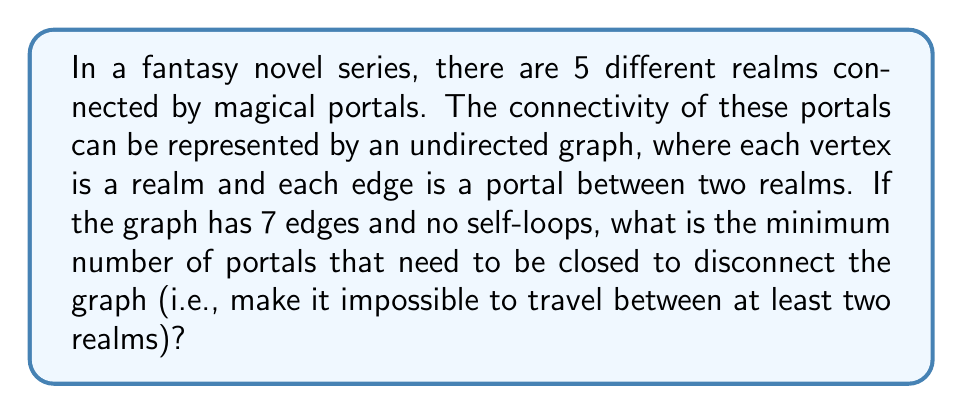Teach me how to tackle this problem. To solve this problem, we need to understand the concept of edge connectivity in graph theory, which is relevant to the topology of networks.

1. First, let's consider the maximum number of edges possible in a graph with 5 vertices:
   $${5 \choose 2} = \frac{5 * 4}{2} = 10$$

2. Our graph has 7 edges out of a possible 10, which means it's likely to be well-connected.

3. The minimum number of edges required to connect 5 vertices is 4 (a tree with 5 vertices). Our graph has 3 extra edges, which form cycles.

4. In graph theory, the edge connectivity of a graph is the minimum number of edges that need to be removed to disconnect the graph.

5. For a graph with $n$ vertices, the maximum possible edge connectivity is $n-1$.

6. Given that our graph is well-connected but not complete, its edge connectivity is likely to be less than the maximum (4 in this case).

7. To disconnect the graph by removing the minimum number of edges, we need to find a "bottleneck" in the graph's structure.

8. With 7 edges distributed among 5 vertices, there must be at least one vertex with degree 3 or higher.

9. The most vulnerable configuration would be if there's a vertex with degree 3 connecting two parts of the graph.

10. Removing these 3 edges would disconnect the graph, and this is the minimum possible number given the constraints.

Therefore, the minimum number of portals that need to be closed to disconnect the graph is 3.
Answer: 3 portals 